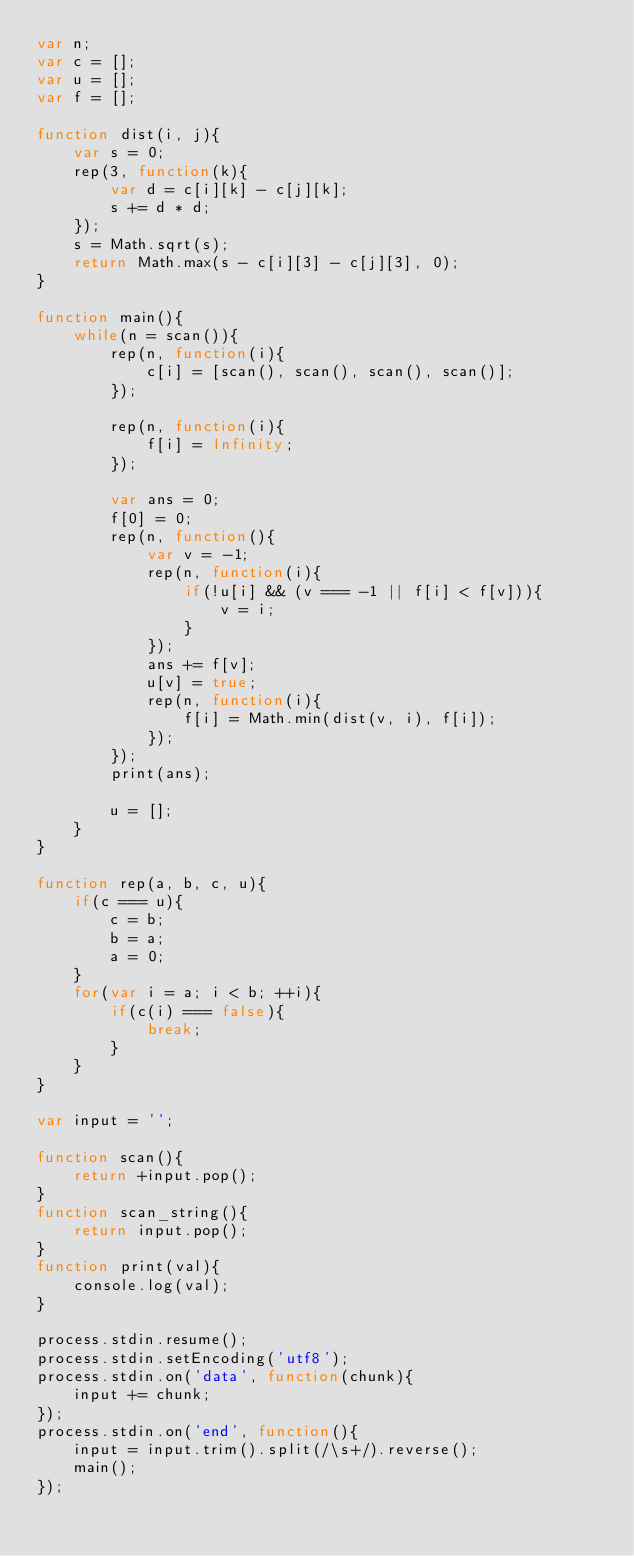Convert code to text. <code><loc_0><loc_0><loc_500><loc_500><_JavaScript_>var n;
var c = [];
var u = [];
var f = [];

function dist(i, j){
	var s = 0;
	rep(3, function(k){
		var d = c[i][k] - c[j][k];
		s += d * d;	
	});
	s = Math.sqrt(s);
	return Math.max(s - c[i][3] - c[j][3], 0);
}

function main(){
	while(n = scan()){
		rep(n, function(i){
			c[i] = [scan(), scan(), scan(), scan()];
		});

		rep(n, function(i){
			f[i] = Infinity;
		});

		var ans = 0;
		f[0] = 0;
		rep(n, function(){
			var v = -1;
			rep(n, function(i){
				if(!u[i] && (v === -1 || f[i] < f[v])){
					v = i;
				}
			});
			ans += f[v];
			u[v] = true;
			rep(n, function(i){
				f[i] = Math.min(dist(v, i), f[i]);
			});
		});
		print(ans);

		u = [];
	}
}

function rep(a, b, c, u){
	if(c === u){
		c = b;
		b = a;
		a = 0;
	}
	for(var i = a; i < b; ++i){
		if(c(i) === false){
			break;
		}
	}
}

var input = '';

function scan(){
	return +input.pop();
}
function scan_string(){
	return input.pop();
} 
function print(val){
	console.log(val);
}
 
process.stdin.resume();
process.stdin.setEncoding('utf8');
process.stdin.on('data', function(chunk){
	input += chunk;
});
process.stdin.on('end', function(){
	input = input.trim().split(/\s+/).reverse();
	main();
});</code> 